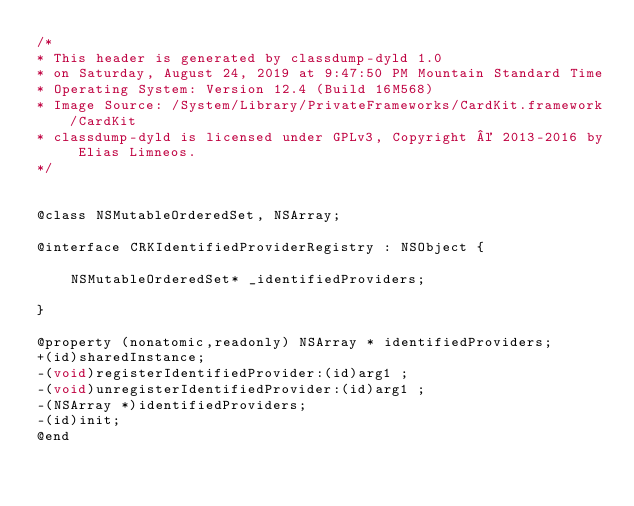Convert code to text. <code><loc_0><loc_0><loc_500><loc_500><_C_>/*
* This header is generated by classdump-dyld 1.0
* on Saturday, August 24, 2019 at 9:47:50 PM Mountain Standard Time
* Operating System: Version 12.4 (Build 16M568)
* Image Source: /System/Library/PrivateFrameworks/CardKit.framework/CardKit
* classdump-dyld is licensed under GPLv3, Copyright © 2013-2016 by Elias Limneos.
*/


@class NSMutableOrderedSet, NSArray;

@interface CRKIdentifiedProviderRegistry : NSObject {

	NSMutableOrderedSet* _identifiedProviders;

}

@property (nonatomic,readonly) NSArray * identifiedProviders; 
+(id)sharedInstance;
-(void)registerIdentifiedProvider:(id)arg1 ;
-(void)unregisterIdentifiedProvider:(id)arg1 ;
-(NSArray *)identifiedProviders;
-(id)init;
@end

</code> 